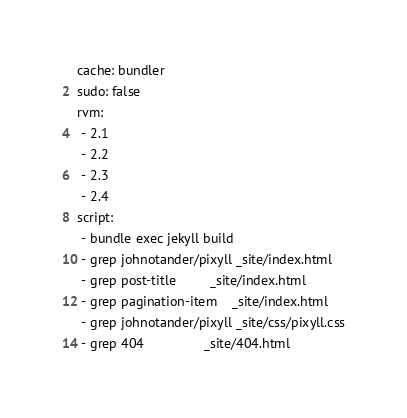Convert code to text. <code><loc_0><loc_0><loc_500><loc_500><_YAML_>cache: bundler
sudo: false
rvm:
 - 2.1
 - 2.2
 - 2.3
 - 2.4
script:
 - bundle exec jekyll build
 - grep johnotander/pixyll _site/index.html
 - grep post-title         _site/index.html
 - grep pagination-item    _site/index.html
 - grep johnotander/pixyll _site/css/pixyll.css
 - grep 404                _site/404.html
</code> 